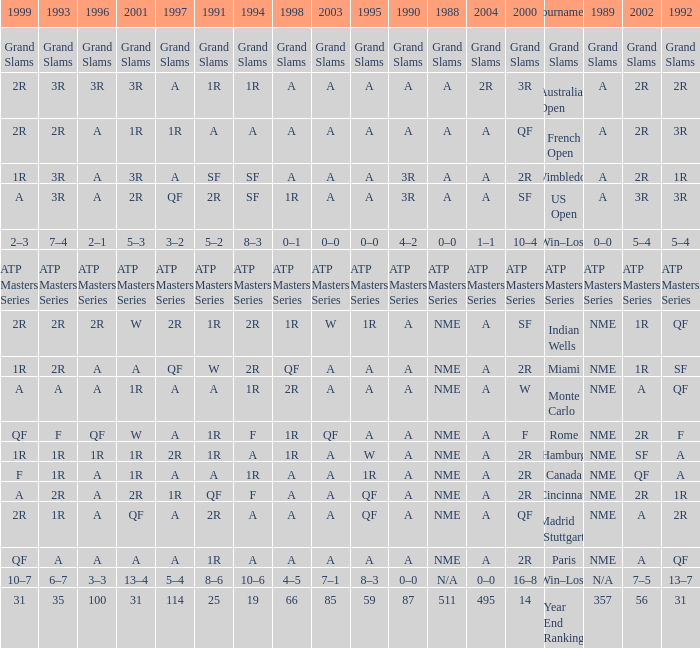What shows for 1988 when 1994 shows 10–6? N/A. 